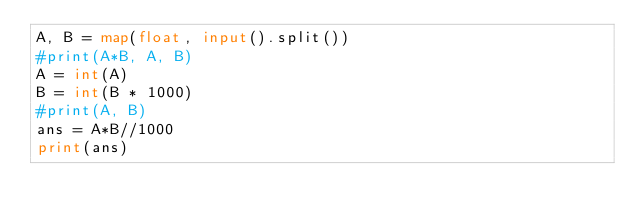<code> <loc_0><loc_0><loc_500><loc_500><_Python_>A, B = map(float, input().split())
#print(A*B, A, B)
A = int(A)
B = int(B * 1000)
#print(A, B)
ans = A*B//1000
print(ans)</code> 